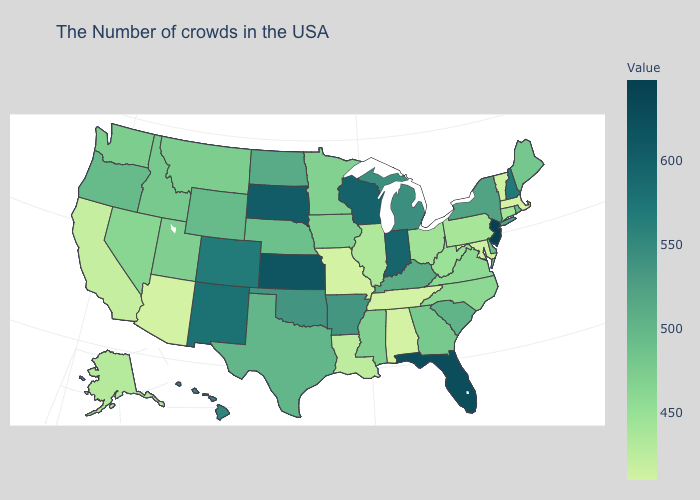Which states have the lowest value in the West?
Short answer required. Arizona. Does the map have missing data?
Give a very brief answer. No. Which states hav the highest value in the South?
Concise answer only. Florida. Among the states that border Maryland , does Delaware have the highest value?
Short answer required. Yes. Does New Jersey have the highest value in the USA?
Write a very short answer. Yes. Among the states that border Delaware , which have the highest value?
Write a very short answer. New Jersey. Which states hav the highest value in the Northeast?
Concise answer only. New Jersey. 